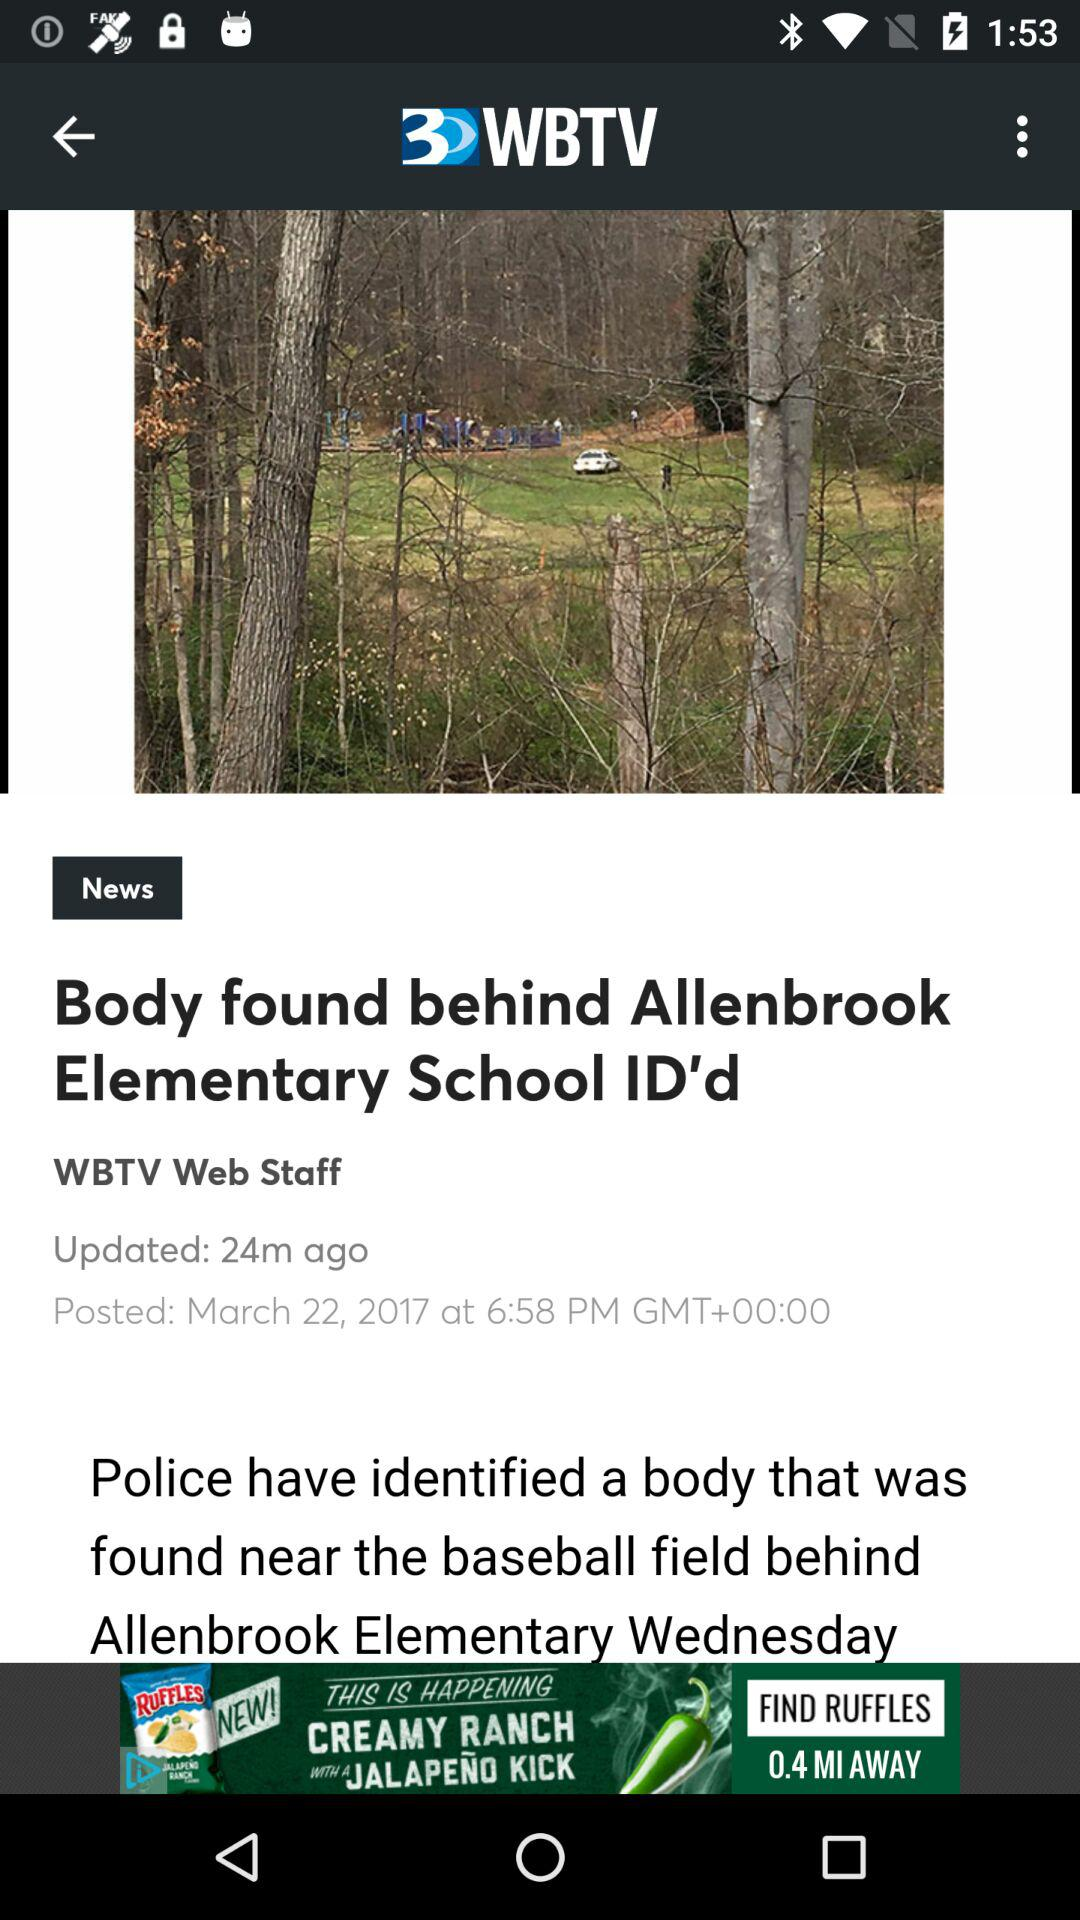How many minutes ago was the article posted?
Answer the question using a single word or phrase. 24 